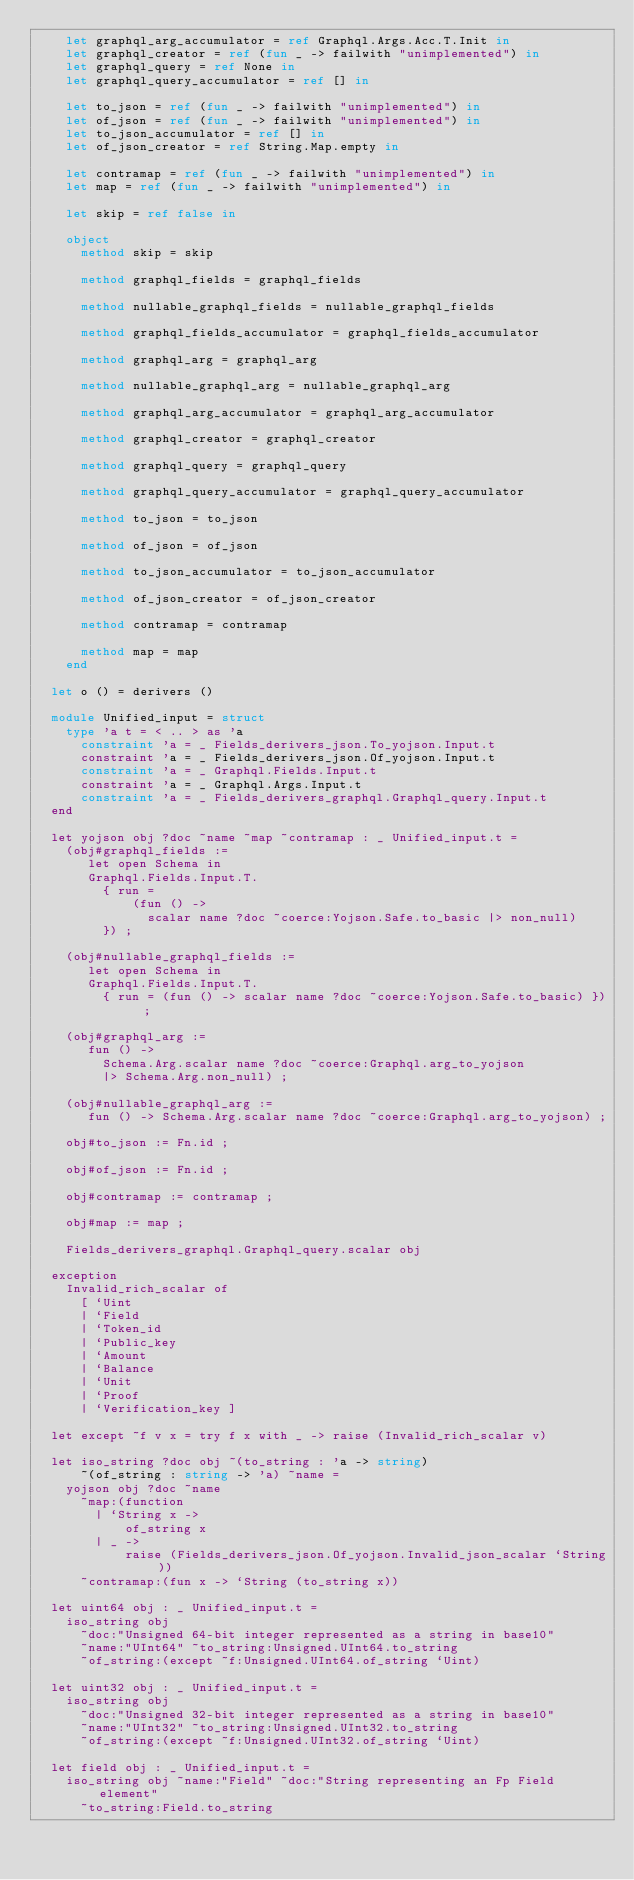<code> <loc_0><loc_0><loc_500><loc_500><_OCaml_>    let graphql_arg_accumulator = ref Graphql.Args.Acc.T.Init in
    let graphql_creator = ref (fun _ -> failwith "unimplemented") in
    let graphql_query = ref None in
    let graphql_query_accumulator = ref [] in

    let to_json = ref (fun _ -> failwith "unimplemented") in
    let of_json = ref (fun _ -> failwith "unimplemented") in
    let to_json_accumulator = ref [] in
    let of_json_creator = ref String.Map.empty in

    let contramap = ref (fun _ -> failwith "unimplemented") in
    let map = ref (fun _ -> failwith "unimplemented") in

    let skip = ref false in

    object
      method skip = skip

      method graphql_fields = graphql_fields

      method nullable_graphql_fields = nullable_graphql_fields

      method graphql_fields_accumulator = graphql_fields_accumulator

      method graphql_arg = graphql_arg

      method nullable_graphql_arg = nullable_graphql_arg

      method graphql_arg_accumulator = graphql_arg_accumulator

      method graphql_creator = graphql_creator

      method graphql_query = graphql_query

      method graphql_query_accumulator = graphql_query_accumulator

      method to_json = to_json

      method of_json = of_json

      method to_json_accumulator = to_json_accumulator

      method of_json_creator = of_json_creator

      method contramap = contramap

      method map = map
    end

  let o () = derivers ()

  module Unified_input = struct
    type 'a t = < .. > as 'a
      constraint 'a = _ Fields_derivers_json.To_yojson.Input.t
      constraint 'a = _ Fields_derivers_json.Of_yojson.Input.t
      constraint 'a = _ Graphql.Fields.Input.t
      constraint 'a = _ Graphql.Args.Input.t
      constraint 'a = _ Fields_derivers_graphql.Graphql_query.Input.t
  end

  let yojson obj ?doc ~name ~map ~contramap : _ Unified_input.t =
    (obj#graphql_fields :=
       let open Schema in
       Graphql.Fields.Input.T.
         { run =
             (fun () ->
               scalar name ?doc ~coerce:Yojson.Safe.to_basic |> non_null)
         }) ;

    (obj#nullable_graphql_fields :=
       let open Schema in
       Graphql.Fields.Input.T.
         { run = (fun () -> scalar name ?doc ~coerce:Yojson.Safe.to_basic) }) ;

    (obj#graphql_arg :=
       fun () ->
         Schema.Arg.scalar name ?doc ~coerce:Graphql.arg_to_yojson
         |> Schema.Arg.non_null) ;

    (obj#nullable_graphql_arg :=
       fun () -> Schema.Arg.scalar name ?doc ~coerce:Graphql.arg_to_yojson) ;

    obj#to_json := Fn.id ;

    obj#of_json := Fn.id ;

    obj#contramap := contramap ;

    obj#map := map ;

    Fields_derivers_graphql.Graphql_query.scalar obj

  exception
    Invalid_rich_scalar of
      [ `Uint
      | `Field
      | `Token_id
      | `Public_key
      | `Amount
      | `Balance
      | `Unit
      | `Proof
      | `Verification_key ]

  let except ~f v x = try f x with _ -> raise (Invalid_rich_scalar v)

  let iso_string ?doc obj ~(to_string : 'a -> string)
      ~(of_string : string -> 'a) ~name =
    yojson obj ?doc ~name
      ~map:(function
        | `String x ->
            of_string x
        | _ ->
            raise (Fields_derivers_json.Of_yojson.Invalid_json_scalar `String))
      ~contramap:(fun x -> `String (to_string x))

  let uint64 obj : _ Unified_input.t =
    iso_string obj
      ~doc:"Unsigned 64-bit integer represented as a string in base10"
      ~name:"UInt64" ~to_string:Unsigned.UInt64.to_string
      ~of_string:(except ~f:Unsigned.UInt64.of_string `Uint)

  let uint32 obj : _ Unified_input.t =
    iso_string obj
      ~doc:"Unsigned 32-bit integer represented as a string in base10"
      ~name:"UInt32" ~to_string:Unsigned.UInt32.to_string
      ~of_string:(except ~f:Unsigned.UInt32.of_string `Uint)

  let field obj : _ Unified_input.t =
    iso_string obj ~name:"Field" ~doc:"String representing an Fp Field element"
      ~to_string:Field.to_string</code> 